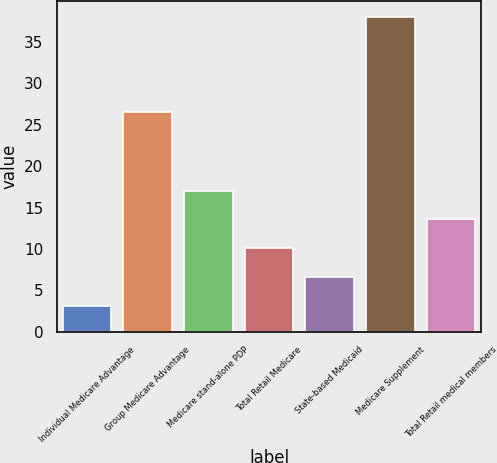Convert chart to OTSL. <chart><loc_0><loc_0><loc_500><loc_500><bar_chart><fcel>Individual Medicare Advantage<fcel>Group Medicare Advantage<fcel>Medicare stand-alone PDP<fcel>Total Retail Medicare<fcel>State-based Medicaid<fcel>Medicare Supplement<fcel>Total Retail medical members<nl><fcel>3.1<fcel>26.6<fcel>17.06<fcel>10.08<fcel>6.59<fcel>38<fcel>13.57<nl></chart> 